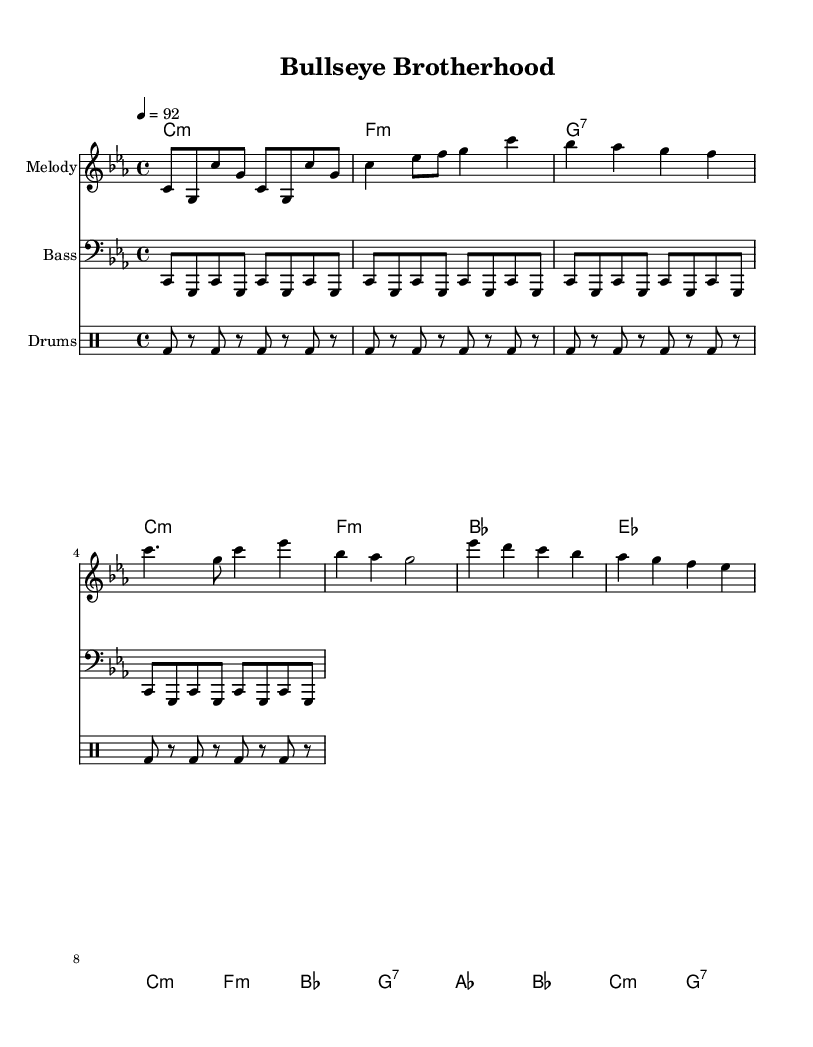What is the key signature of this music? The key signature is C minor, which has three flats: B flat, E flat, and A flat.
Answer: C minor What is the time signature of this music? The time signature is shown at the beginning, and it indicates how many beats are in each measure. Here, it reads 4/4, meaning there are four beats per measure, and a quarter note receives one beat.
Answer: 4/4 What is the tempo marking found in the music? The tempo marking is notated at the beginning of the score and indicates the speed of the music. It specifies a tempo of 92 beats per minute.
Answer: 92 How many measures are present in the intro section? By counting the measures in the intro, which consists of a specific number of bars, we can quantify them easily. The intro includes four measures repeated once. Thus, there are four measures total.
Answer: 4 What chords are used in the chorus? To determine the chords in the chorus, we look at the chord changes lined up with the melody notes during the chorus section. The recorded chords are C minor, F minor, B flat, and G seventh.
Answer: C minor, F minor, B flat, G seventh What rhythmic pattern is used in the drum part? Analyzing the drum pattern indicates the specific rhythm used across the measures. In this case, there is a repeated pattern of bass drum hits and rests, which is consistent throughout the section.
Answer: Bass drum with rests How does the melody relate to the community theme in rap music? The melody is designed to evoke feelings often found in community-oriented subject matter such as camaraderie and training. The combination of chords supports themes prevalent in rap about unity, purpose, and shared goals, making it ideal for lyrical content centered on these topics.
Answer: Unity and purpose 